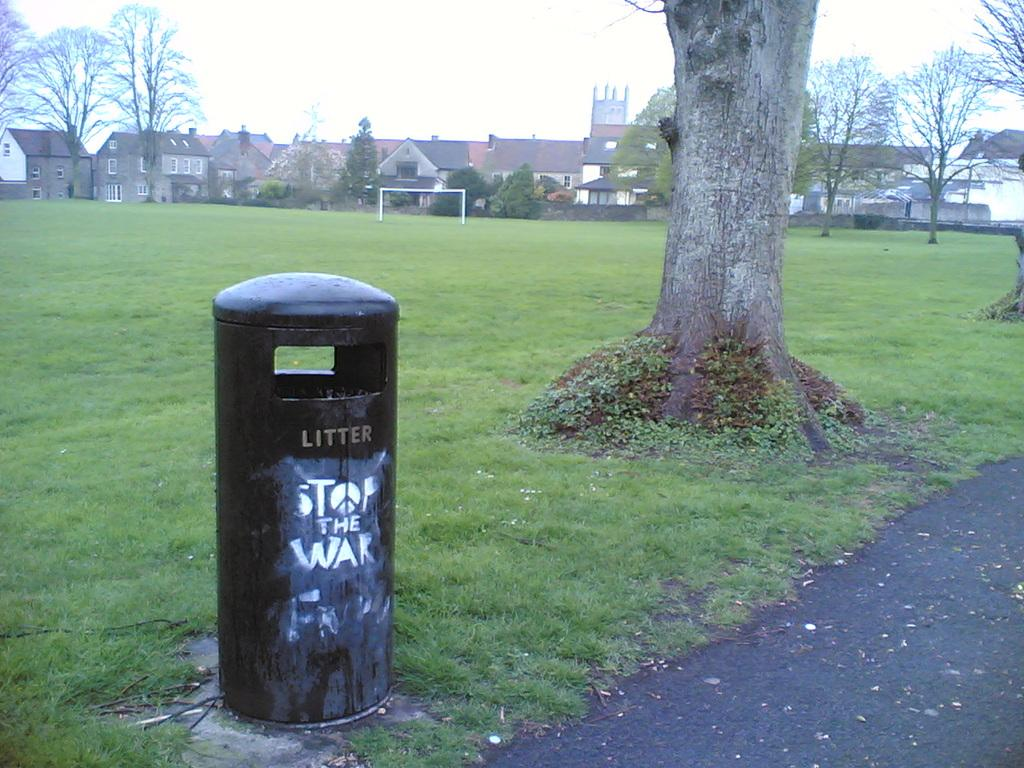<image>
Relay a brief, clear account of the picture shown. Someone has spray painted stop the war on a litter can in a park. 